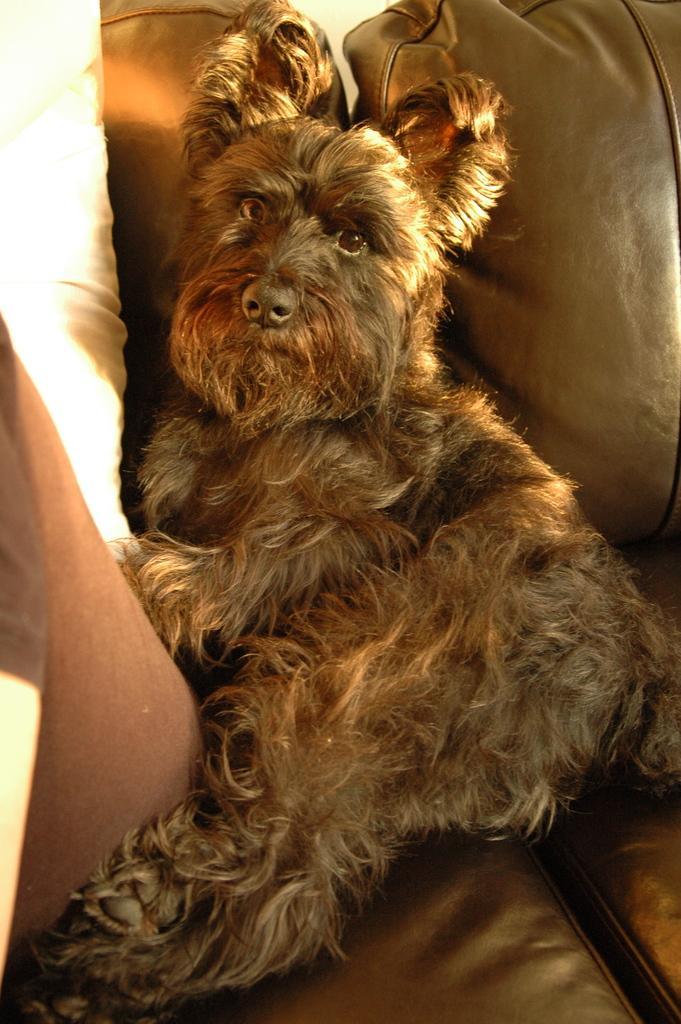How would you summarize this image in a sentence or two? In this picture we can see a dog and there are pillows. 